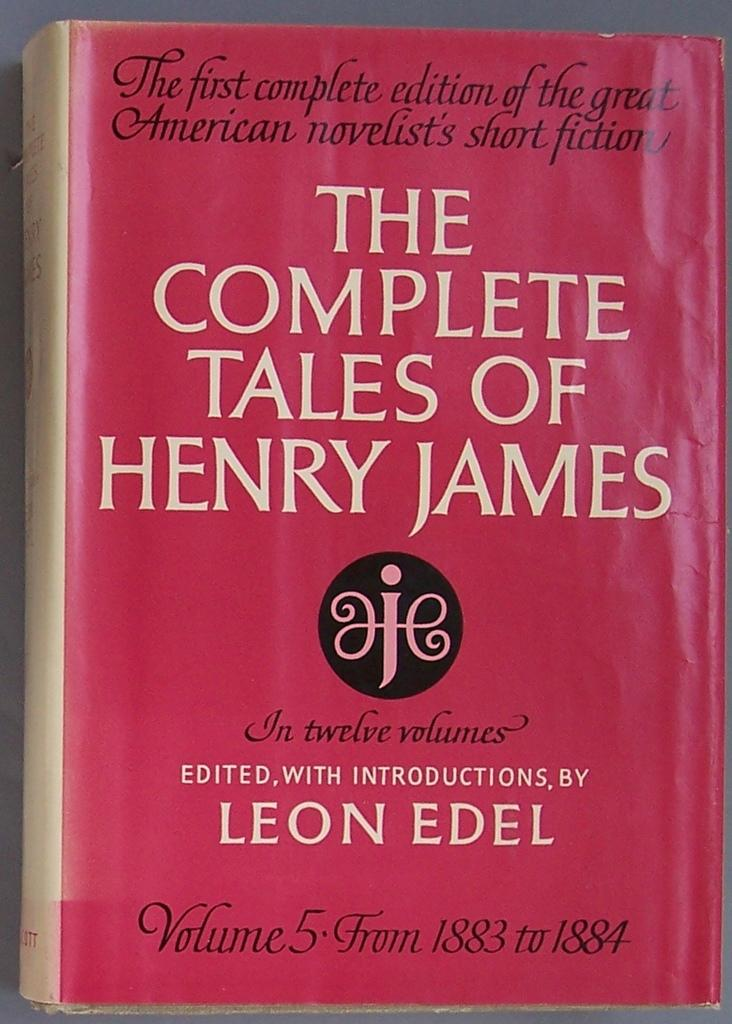What is the main subject of the image? The main subject of the image is a book. Where is the book located in the image? The book is in the center of the image. What can be seen on the book? The book has some text on it. Can you see any worms crawling on the book in the image? There are no worms visible on the book in the image. What color is the patch on the book? There is no patch present on the book in the image. 